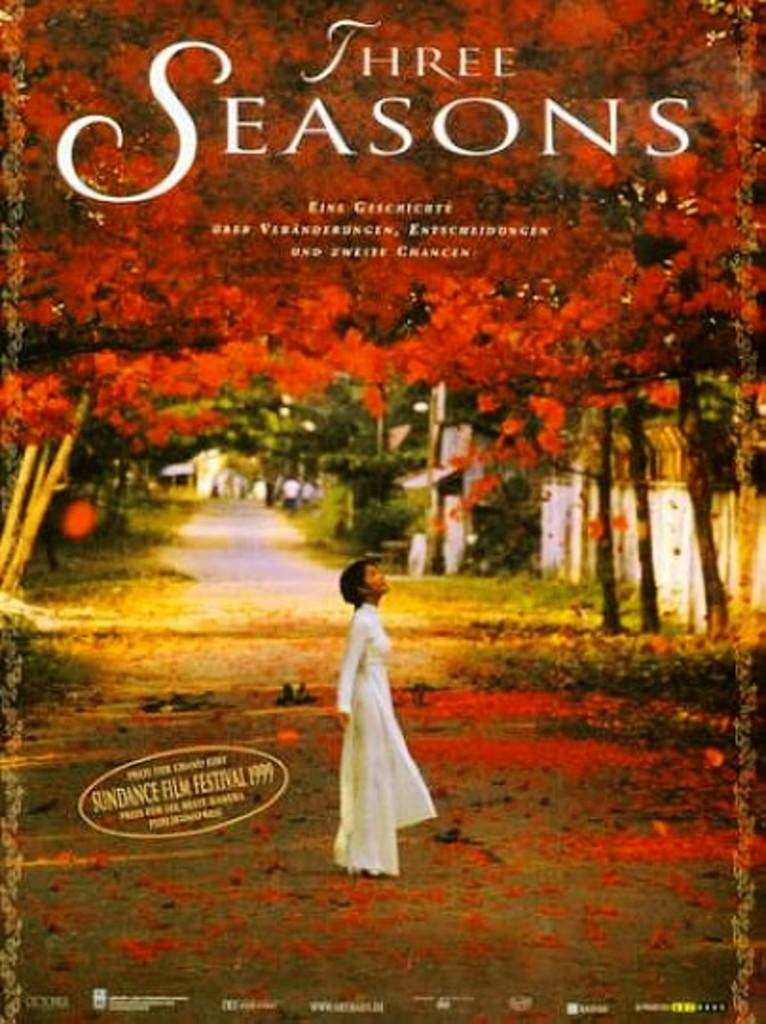<image>
Summarize the visual content of the image. A brightly colored poster advertising the film "Three Seasons" 